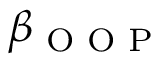Convert formula to latex. <formula><loc_0><loc_0><loc_500><loc_500>\beta _ { O O P }</formula> 